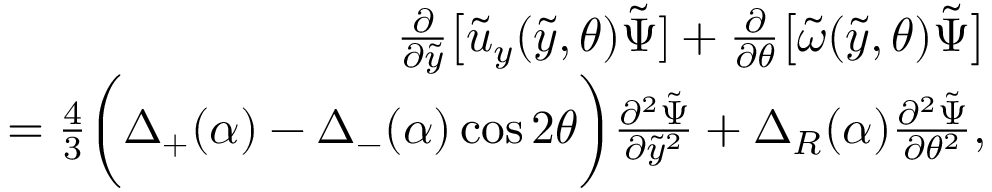Convert formula to latex. <formula><loc_0><loc_0><loc_500><loc_500>\begin{array} { r l r } & { \frac { \partial } { \partial \tilde { y } } \Big [ \tilde { u } _ { y } ( \tilde { y } , \theta ) \tilde { \Psi } ] + \frac { \partial } { \partial \theta } \Big [ \tilde { \omega } ( \tilde { y } , \theta ) \tilde { \Psi } \Big ] } \\ & { \quad \, = \frac { 4 } { 3 } \Big ( \Delta _ { + } ( \alpha ) - \Delta _ { - } ( \alpha ) \cos { 2 \theta } \Big ) \frac { \partial ^ { 2 } \tilde { \Psi } } { \partial \tilde { y } ^ { 2 } } + \Delta _ { R } ( \alpha ) \frac { \partial ^ { 2 } \tilde { \Psi } } { \partial \theta ^ { 2 } } , } \end{array}</formula> 